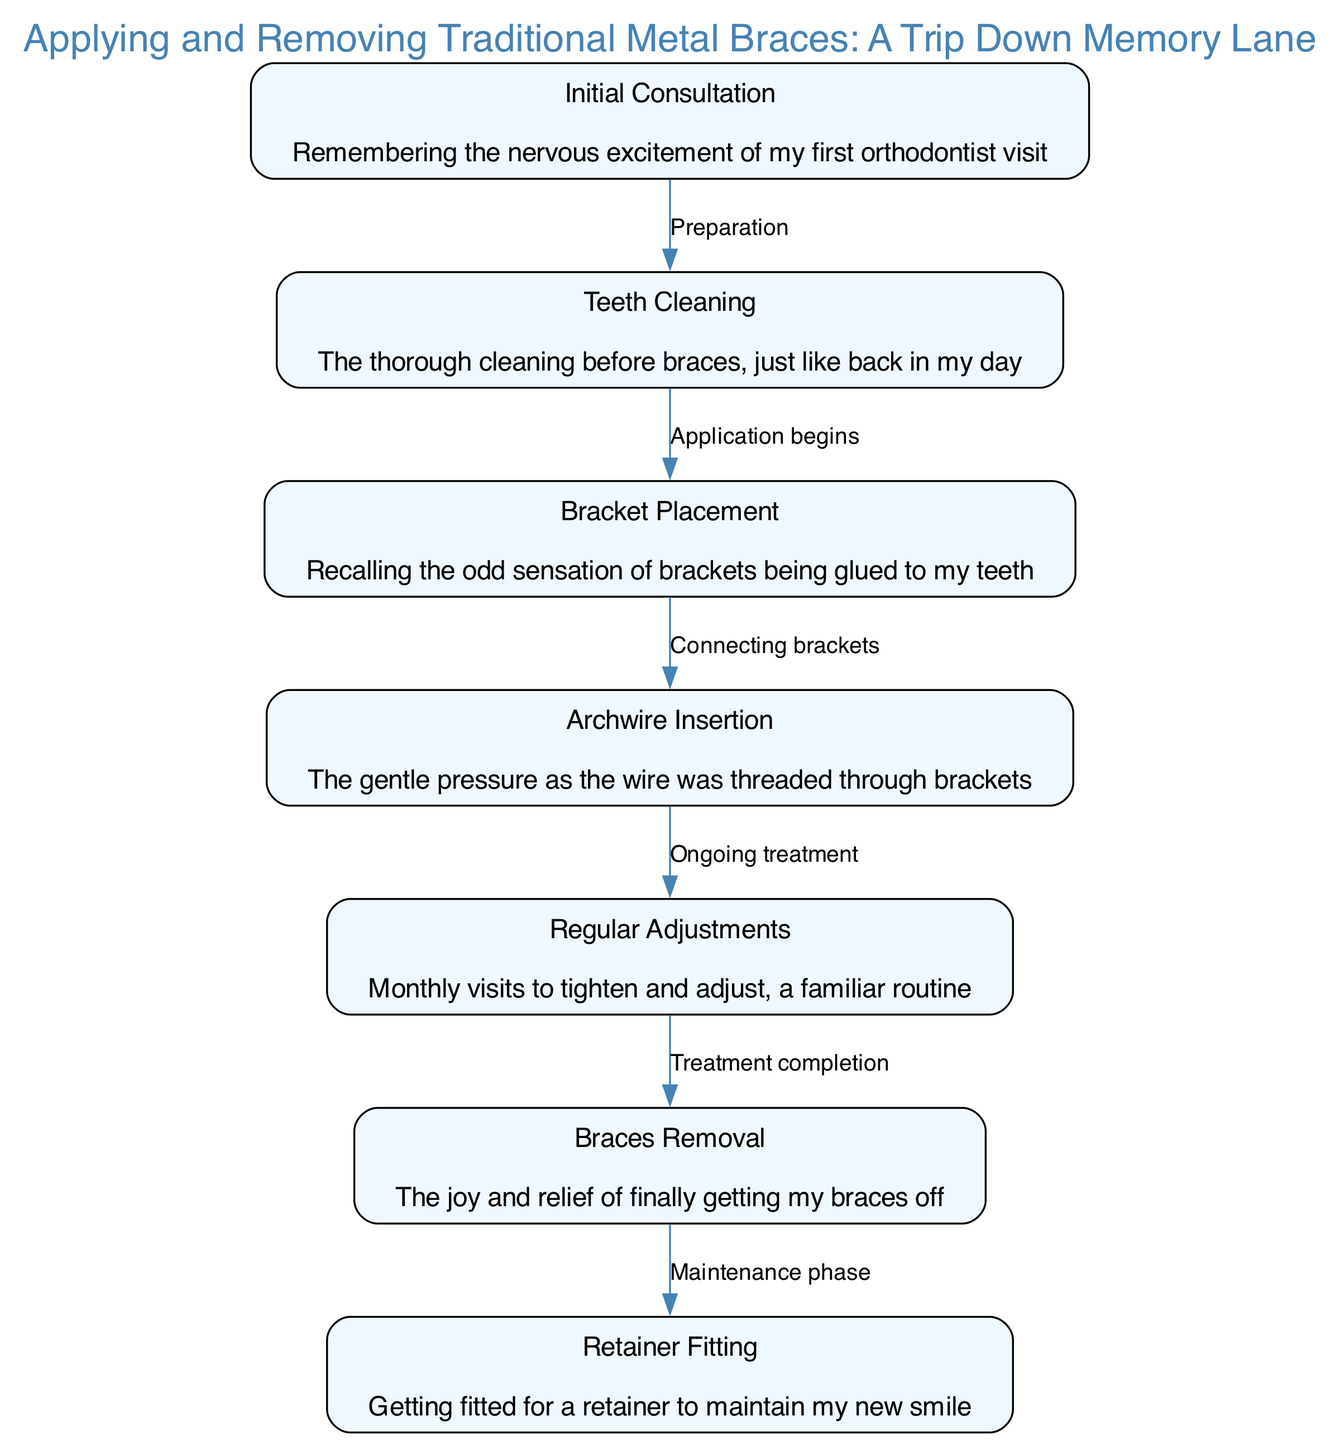What is the first step in the braces application process? The first step is the "Initial Consultation," which is indicated as the starting node in the diagram. It sets the tone for the entire procedure that follows.
Answer: Initial Consultation How many main steps are there in the entire process? By counting the nodes listed in the diagram, we find there are seven main steps in the braces application and removal process.
Answer: Seven What happens after the "Teeth Cleaning"? After "Teeth Cleaning," the next step is "Bracket Placement," which is indicated by the arrow connecting the two nodes.
Answer: Bracket Placement Which step represents a familiar routine for regular visits? The step representing a familiar routine for regular visits is "Regular Adjustments," as indicated in the description of this specific node.
Answer: Regular Adjustments What is the last step before starting the maintenance phase? The last step before starting the maintenance phase is "Braces Removal," as denoted in the diagram leading to the retainer fitting.
Answer: Braces Removal In which step do you experience the gentle pressure from the wire? The experience of gentle pressure from the wire occurs during the "Archwire Insertion," which is explicitly mentioned in the description for that node.
Answer: Archwire Insertion What type of fitting follows after the braces are removed? After the braces are removed, the next fitting is for a "Retainer," as shown in the final step of the diagram.
Answer: Retainer Which two steps are connected by the label "Connecting brackets"? The two steps connected by the label "Connecting brackets" are "Bracket Placement" and "Archwire Insertion," clearly illustrated by their directional edge.
Answer: Bracket Placement and Archwire Insertion 